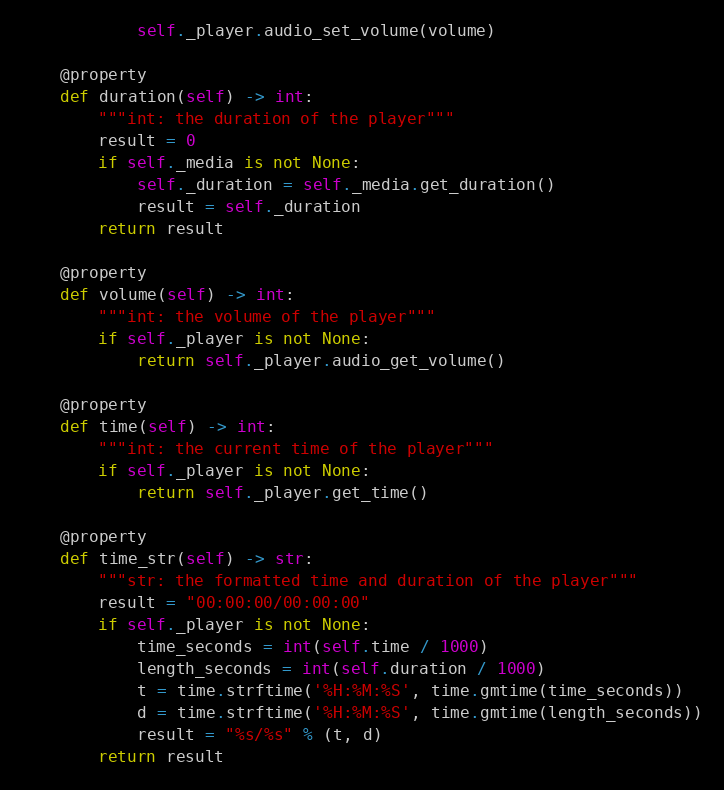<code> <loc_0><loc_0><loc_500><loc_500><_Python_>            self._player.audio_set_volume(volume)

    @property
    def duration(self) -> int:
        """int: the duration of the player"""
        result = 0
        if self._media is not None:
            self._duration = self._media.get_duration()
            result = self._duration
        return result

    @property
    def volume(self) -> int:
        """int: the volume of the player"""
        if self._player is not None:
            return self._player.audio_get_volume()

    @property
    def time(self) -> int:
        """int: the current time of the player"""
        if self._player is not None:
            return self._player.get_time()

    @property
    def time_str(self) -> str:
        """str: the formatted time and duration of the player"""
        result = "00:00:00/00:00:00"
        if self._player is not None:
            time_seconds = int(self.time / 1000)
            length_seconds = int(self.duration / 1000)
            t = time.strftime('%H:%M:%S', time.gmtime(time_seconds))
            d = time.strftime('%H:%M:%S', time.gmtime(length_seconds))
            result = "%s/%s" % (t, d)
        return result
</code> 